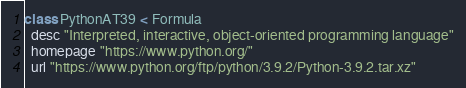Convert code to text. <code><loc_0><loc_0><loc_500><loc_500><_Ruby_>class PythonAT39 < Formula
  desc "Interpreted, interactive, object-oriented programming language"
  homepage "https://www.python.org/"
  url "https://www.python.org/ftp/python/3.9.2/Python-3.9.2.tar.xz"</code> 